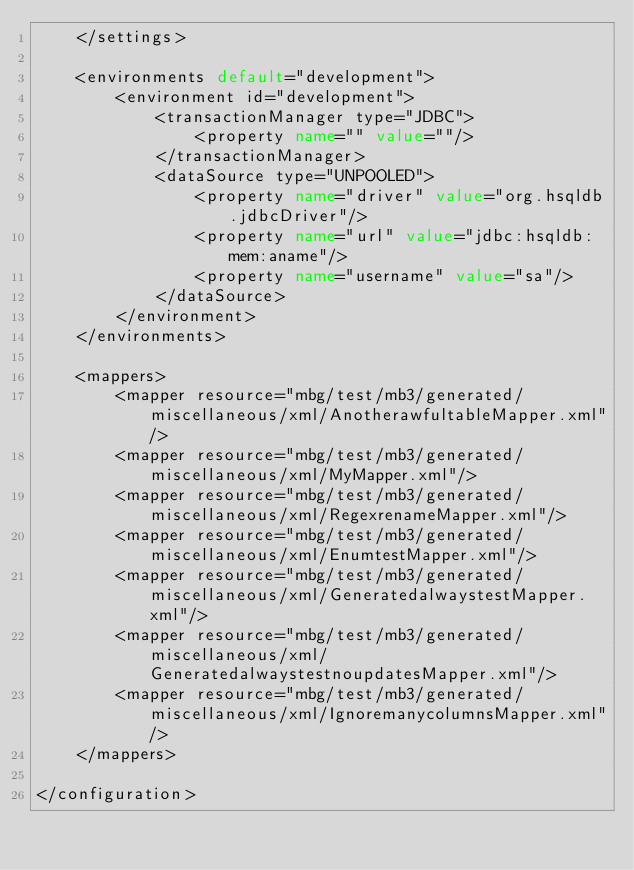Convert code to text. <code><loc_0><loc_0><loc_500><loc_500><_XML_>    </settings>

    <environments default="development">
        <environment id="development">
            <transactionManager type="JDBC">
                <property name="" value=""/>
            </transactionManager>
            <dataSource type="UNPOOLED">
                <property name="driver" value="org.hsqldb.jdbcDriver"/>
                <property name="url" value="jdbc:hsqldb:mem:aname"/>
                <property name="username" value="sa"/>
            </dataSource>
        </environment>
    </environments>

    <mappers>
        <mapper resource="mbg/test/mb3/generated/miscellaneous/xml/AnotherawfultableMapper.xml"/>
        <mapper resource="mbg/test/mb3/generated/miscellaneous/xml/MyMapper.xml"/>
        <mapper resource="mbg/test/mb3/generated/miscellaneous/xml/RegexrenameMapper.xml"/>
        <mapper resource="mbg/test/mb3/generated/miscellaneous/xml/EnumtestMapper.xml"/>
        <mapper resource="mbg/test/mb3/generated/miscellaneous/xml/GeneratedalwaystestMapper.xml"/>
        <mapper resource="mbg/test/mb3/generated/miscellaneous/xml/GeneratedalwaystestnoupdatesMapper.xml"/>
        <mapper resource="mbg/test/mb3/generated/miscellaneous/xml/IgnoremanycolumnsMapper.xml"/>
    </mappers>

</configuration>
</code> 